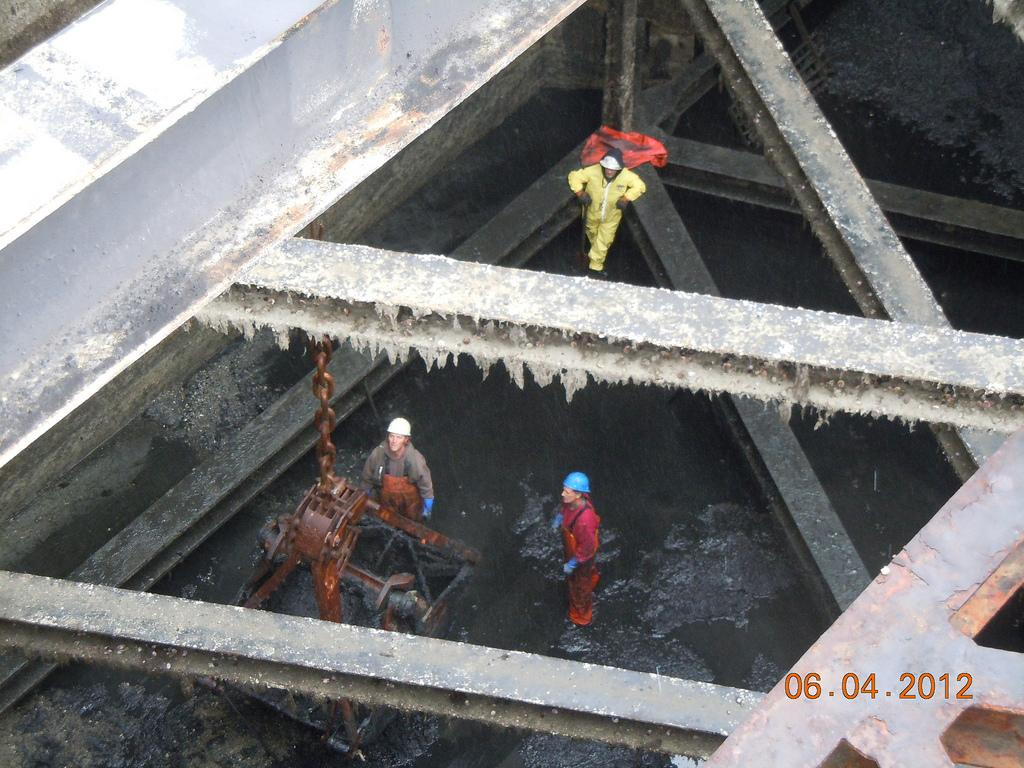What are the people in the image wearing on their heads? The people in the image are wearing helmets. What can be seen in the background of the image? There are poles in the image. What is the liquid visible in the image? Drainage water is visible in the image. What type of object is attached to a chain in the image? There is a metal object with a chain in the image. Where can the date be found in the image? The date is present in the bottom right side of the image. How many fingers can be seen pointing at the print in the image? There is no print or fingers pointing at it in the image. 